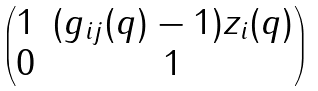<formula> <loc_0><loc_0><loc_500><loc_500>\begin{pmatrix} 1 & ( g _ { i j } ( q ) - 1 ) z _ { i } ( q ) \\ 0 & 1 \end{pmatrix}</formula> 